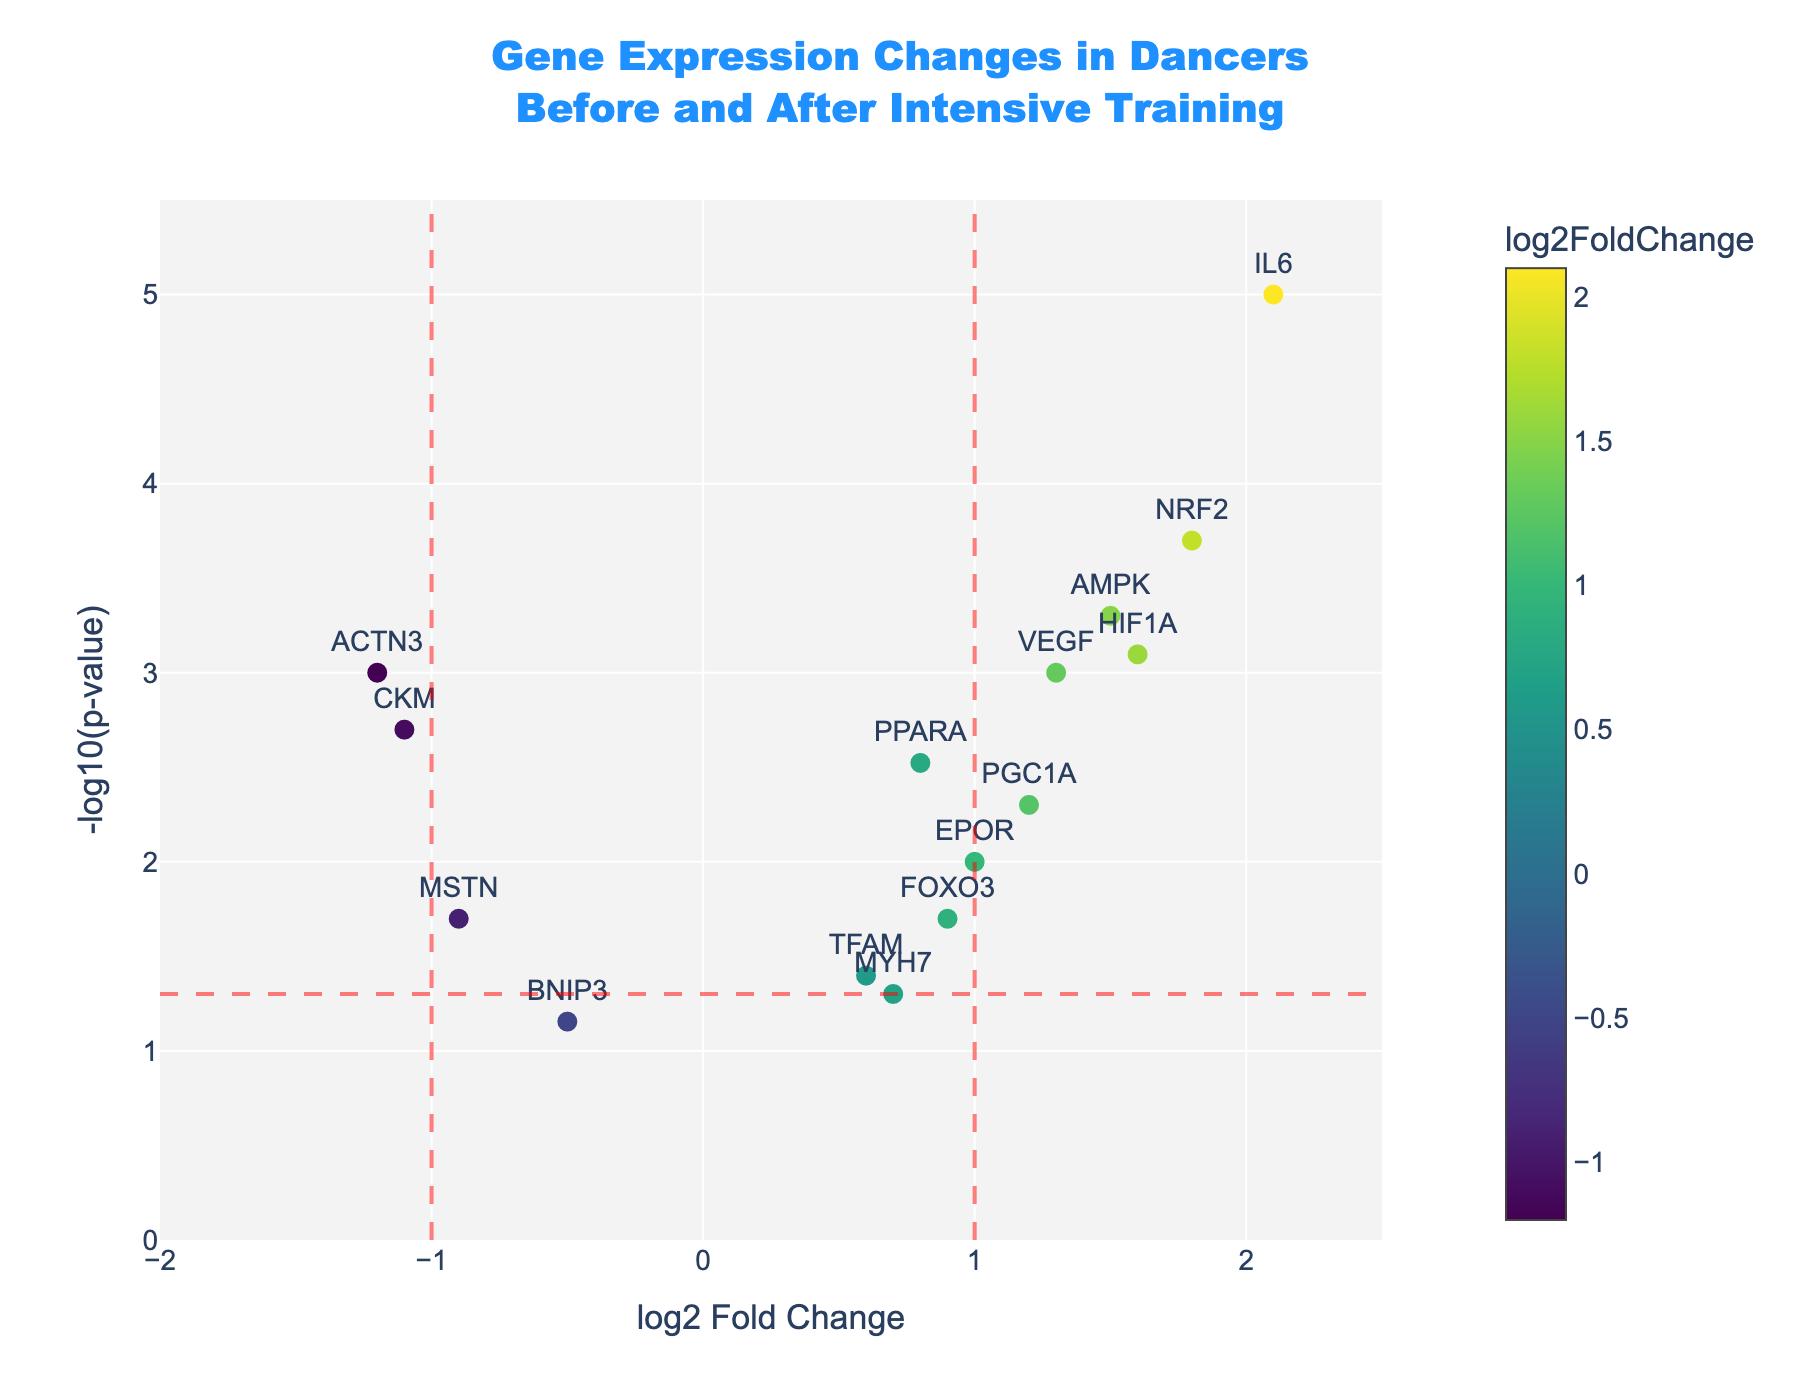What's the title of the plot? The title is located at the top of the plot and reads "Gene Expression Changes in Dancers Before and After Intensive Training."
Answer: Gene Expression Changes in Dancers Before and After Intensive Training What does the x-axis represent? The x-axis represents the log2 Fold Change of gene expression levels before and after intensive training.
Answer: log2 Fold Change What does the y-axis represent? The y-axis represents the -log10(p-value) of the gene expression changes.
Answer: -log10(p-value) Which gene has the highest -log10(p-value)? By examining the y-axis, the gene IL6 has the highest value of -log10(p-value).
Answer: IL6 Which gene has the largest positive log2 Fold Change? The gene with the highest log2 Fold Change value on the x-axis is IL6.
Answer: IL6 How many genes have a significant change in expression (p-value < 0.05)? Significant genes are those above the horizontal red dashed line at -log10(0.05). There are 13 significant genes: ACTN3, PPARA, MSTN, AMPK, IL6, VEGF, CKM, EPOR, NRF2, PGC1A, FOXO3, and HIF1A.
Answer: 13 What's the median log2 Fold Change for all genes? To find the median log2 Fold Change, first order the values and find the middle one, which is 0.9 (values: -1.2, -1.1, -0.9, -0.5, 0.6, 0.7, 0.8, 0.9, 1.0, 1.2, 1.3, 1.5, 1.6, 1.8, 2.1).
Answer: 0.9 Which genes have a log2 Fold Change less than -1? The genes that fall to the left of the -1 vertical dashed line are ACTN3 and CKM.
Answer: ACTN3 and CKM How does the gene AMPK compare to the gene PPARA in terms of log2 Fold Change? AMPK has a log2 Fold Change of 1.5, which is greater than PPARA's log2 Fold Change of 0.8.
Answer: AMPK > PPARA What color indicates a positive log2 Fold Change? Looking at the color gradient, a positive log2 Fold Change is indicated by colors on the green to yellow spectrum.
Answer: Green to yellow 